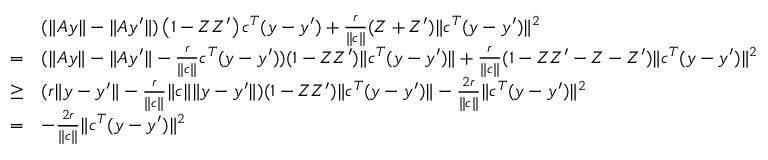<formula> <loc_0><loc_0><loc_500><loc_500>\begin{array} { r l } & { ( \| A y \| - \| A y ^ { \prime } \| ) \left ( 1 - Z Z ^ { \prime } \right ) c ^ { T } ( y - y ^ { \prime } ) + \frac { r } { \| c \| } ( Z + Z ^ { \prime } ) \| c ^ { T } ( y - y ^ { \prime } ) \| ^ { 2 } } \\ { = } & { ( \| A y \| - \| A y ^ { \prime } \| - \frac { r } { \| c \| } c ^ { T } ( y - y ^ { \prime } ) ) ( 1 - Z Z ^ { \prime } ) \| c ^ { T } ( y - y ^ { \prime } ) \| + \frac { r } { \| c \| } ( 1 - Z Z ^ { \prime } - Z - Z ^ { \prime } ) \| c ^ { T } ( y - y ^ { \prime } ) \| ^ { 2 } } \\ { \geq } & { ( r \| y - y ^ { \prime } \| - \frac { r } { \| c \| } \| c \| \| y - y ^ { \prime } \| ) ( 1 - Z Z ^ { \prime } ) \| c ^ { T } ( y - y ^ { \prime } ) \| - \frac { 2 r } { \| c \| } \| c ^ { T } ( y - y ^ { \prime } ) \| ^ { 2 } } \\ { = } & { - \frac { 2 r } { \| c \| } \| c ^ { T } ( y - y ^ { \prime } ) \| ^ { 2 } } \end{array}</formula> 